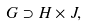Convert formula to latex. <formula><loc_0><loc_0><loc_500><loc_500>G \supset H \times J ,</formula> 